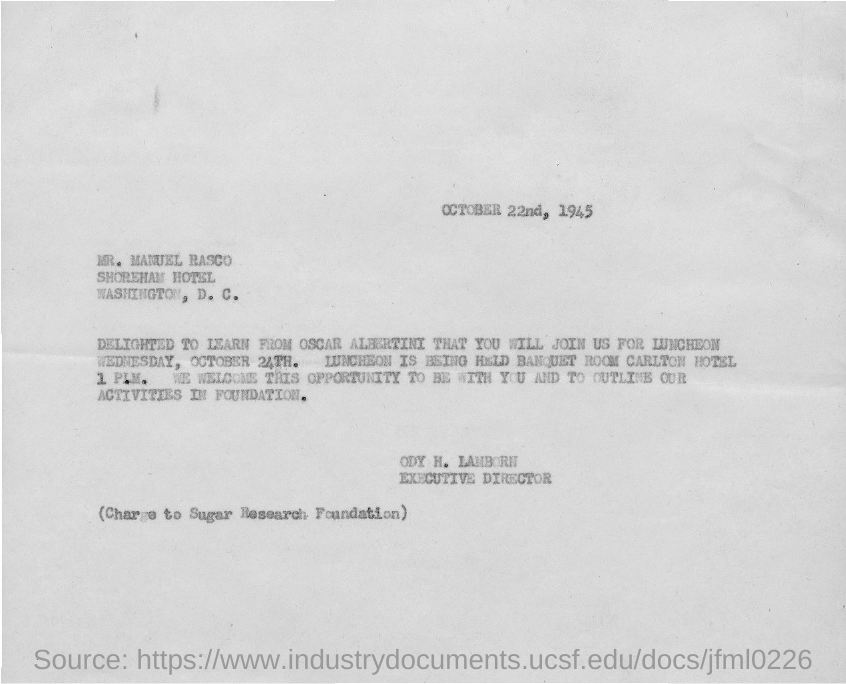Draw attention to some important aspects in this diagram. The sender of this document is ODY H. LAMBORN. The document is addressed to MR. MANUEL RASCO. Ody H. Lamborn is the executive director. 